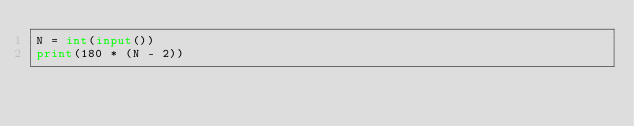Convert code to text. <code><loc_0><loc_0><loc_500><loc_500><_Python_>N = int(input())
print(180 * (N - 2))
</code> 